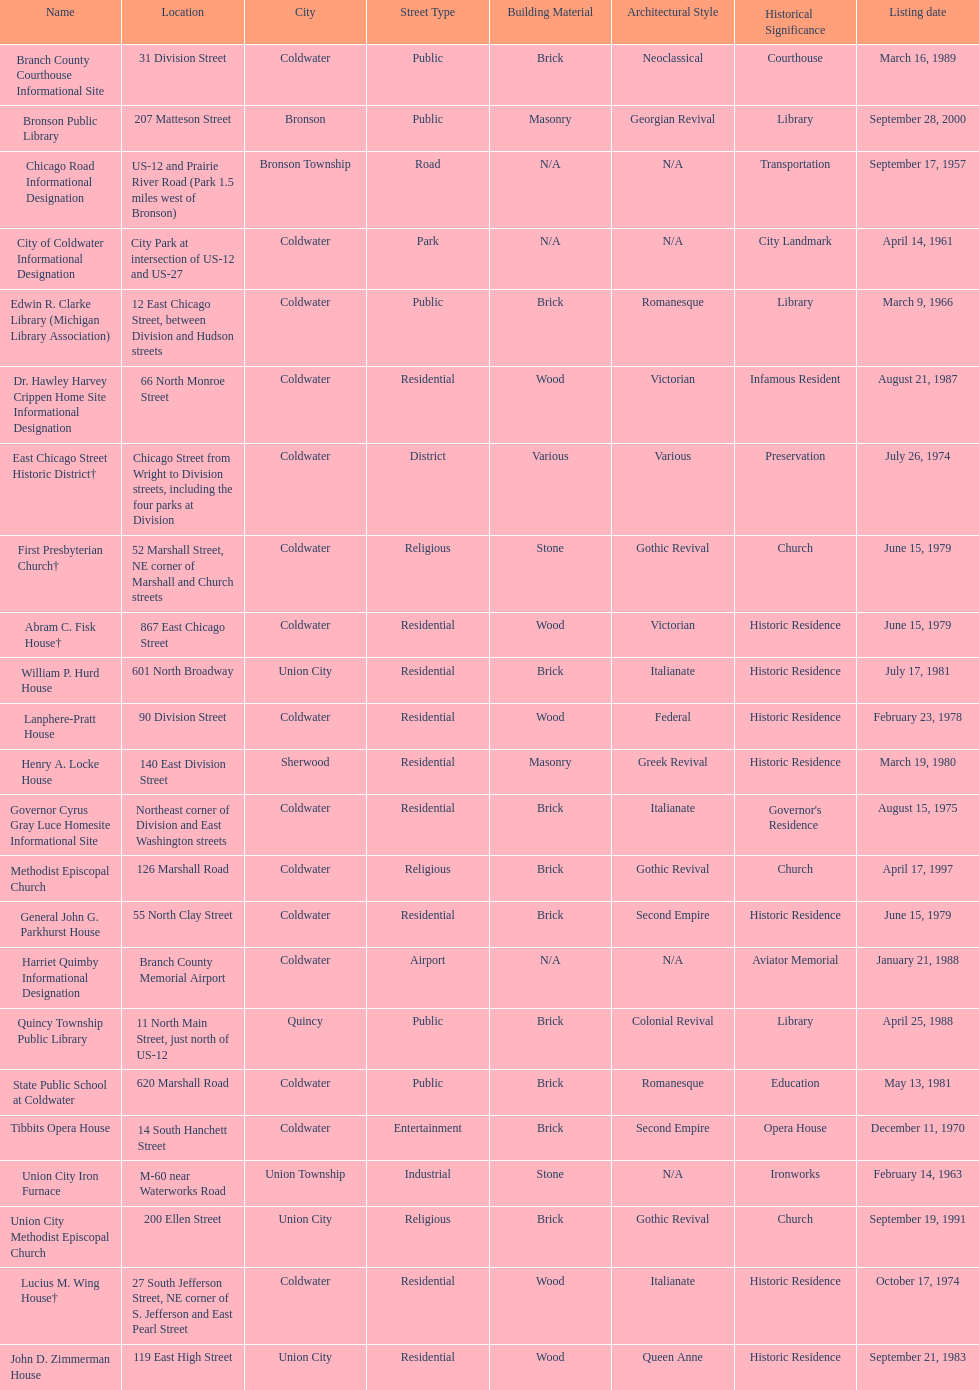How many names are presently included in this chart's listing? 23. 